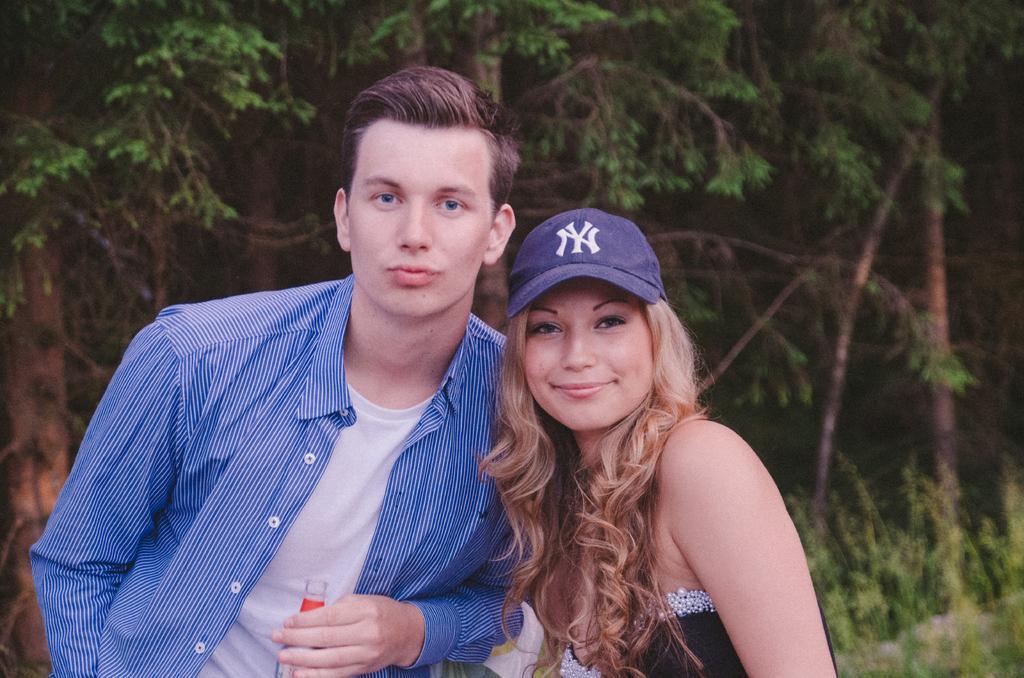How would you summarize this image in a sentence or two? In the picture we can see a man and a woman standing together and a woman is with blue cap and black top and she is smiling and man is with blue shirt and under it we can see a white T-shirt and he is holding a bottle and behind them we can see plants and trees. 